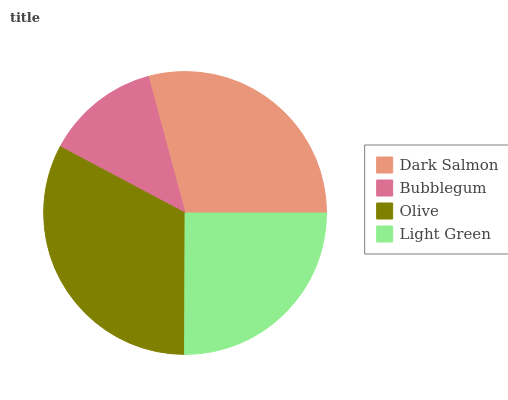Is Bubblegum the minimum?
Answer yes or no. Yes. Is Olive the maximum?
Answer yes or no. Yes. Is Olive the minimum?
Answer yes or no. No. Is Bubblegum the maximum?
Answer yes or no. No. Is Olive greater than Bubblegum?
Answer yes or no. Yes. Is Bubblegum less than Olive?
Answer yes or no. Yes. Is Bubblegum greater than Olive?
Answer yes or no. No. Is Olive less than Bubblegum?
Answer yes or no. No. Is Dark Salmon the high median?
Answer yes or no. Yes. Is Light Green the low median?
Answer yes or no. Yes. Is Olive the high median?
Answer yes or no. No. Is Olive the low median?
Answer yes or no. No. 